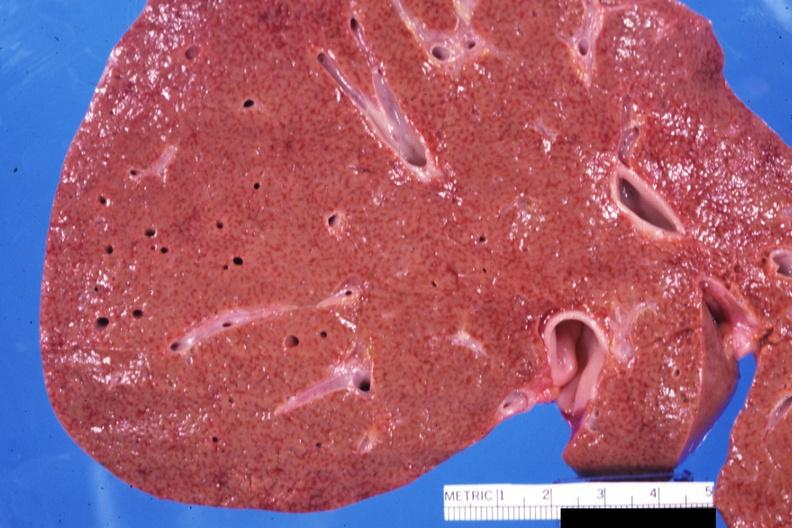does stomach show close-up view of early micronodular cirrhosis quite good?
Answer the question using a single word or phrase. No 